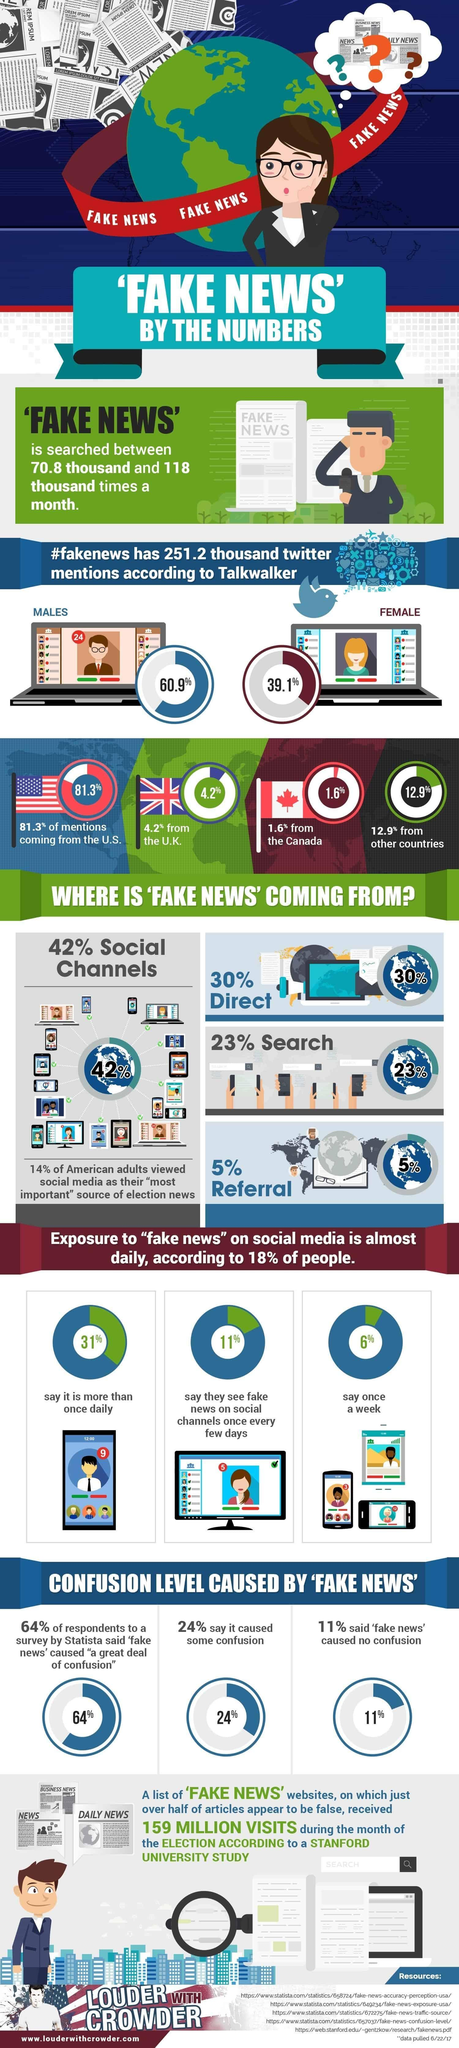What is the fake news generated by US, UK, and Canada?
Answer the question with a short phrase. 87.1% What is the total percentage of people viewing fake news almost once or more than once daily? 42% What percentage of viewers did not feel confused reading fake news, 64%, 24%, or 11%? 11% 